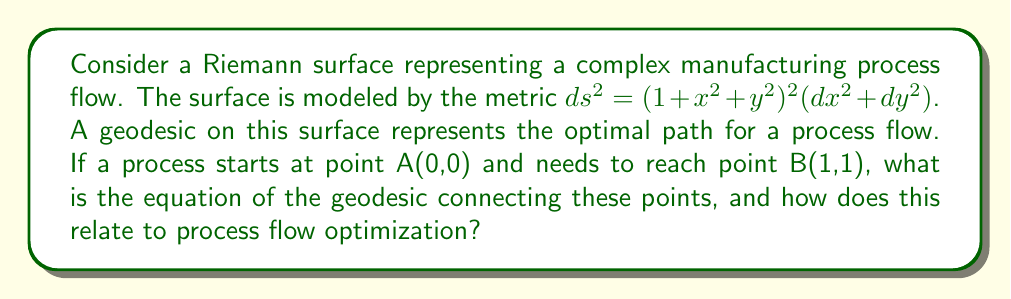Provide a solution to this math problem. To solve this problem, we'll follow these steps:

1) The geodesic equation for a surface with metric $ds^2 = E(x,y)dx^2 + 2F(x,y)dxdy + G(x,y)dy^2$ is given by:

   $$\frac{d^2x}{dt^2} + \Gamma^1_{11}(\frac{dx}{dt})^2 + 2\Gamma^1_{12}\frac{dx}{dt}\frac{dy}{dt} + \Gamma^1_{22}(\frac{dy}{dt})^2 = 0$$
   $$\frac{d^2y}{dt^2} + \Gamma^2_{11}(\frac{dx}{dt})^2 + 2\Gamma^2_{12}\frac{dx}{dt}\frac{dy}{dt} + \Gamma^2_{22}(\frac{dy}{dt})^2 = 0$$

   where $\Gamma^i_{jk}$ are the Christoffel symbols.

2) For our metric, $E = G = (1 + x^2 + y^2)^2$ and $F = 0$. We need to calculate the Christoffel symbols:

   $$\Gamma^1_{11} = \Gamma^2_{22} = \frac{2x}{1+x^2+y^2}$$
   $$\Gamma^1_{22} = \Gamma^2_{11} = -\frac{2x}{1+x^2+y^2}$$
   $$\Gamma^1_{12} = \Gamma^2_{12} = \frac{2y}{1+x^2+y^2}$$

3) Substituting these into the geodesic equations:

   $$\frac{d^2x}{dt^2} + \frac{2x}{1+x^2+y^2}[(\frac{dx}{dt})^2 - (\frac{dy}{dt})^2] + \frac{4y}{1+x^2+y^2}\frac{dx}{dt}\frac{dy}{dt} = 0$$
   $$\frac{d^2y}{dt^2} + \frac{2y}{1+x^2+y^2}[(\frac{dy}{dt})^2 - (\frac{dx}{dt})^2] + \frac{4x}{1+x^2+y^2}\frac{dx}{dt}\frac{dy}{dt} = 0$$

4) These equations are complex and typically require numerical methods to solve. However, given the symmetry of our problem (start at (0,0) and end at (1,1)), we can deduce that the geodesic will follow the straight line $y = x$.

5) Substituting $y = x$ into our metric:

   $$ds^2 = (1 + 2x^2)^2(dx^2 + dx^2) = 2(1 + 2x^2)^2dx^2$$

6) The length of this geodesic is given by:

   $$L = \int_0^1 \sqrt{2}(1 + 2x^2)dx = \sqrt{2}[x + \frac{2}{3}x^3]_0^1 = \sqrt{2}(1 + \frac{2}{3})$$

In terms of process flow optimization, this geodesic represents the optimal path for the process to follow. The equation $y = x$ suggests that the process should progress equally in both dimensions, maintaining a balance. The length of the geodesic represents the total "cost" or "time" of the process, which is minimized by following this path.
Answer: $y = x$ 